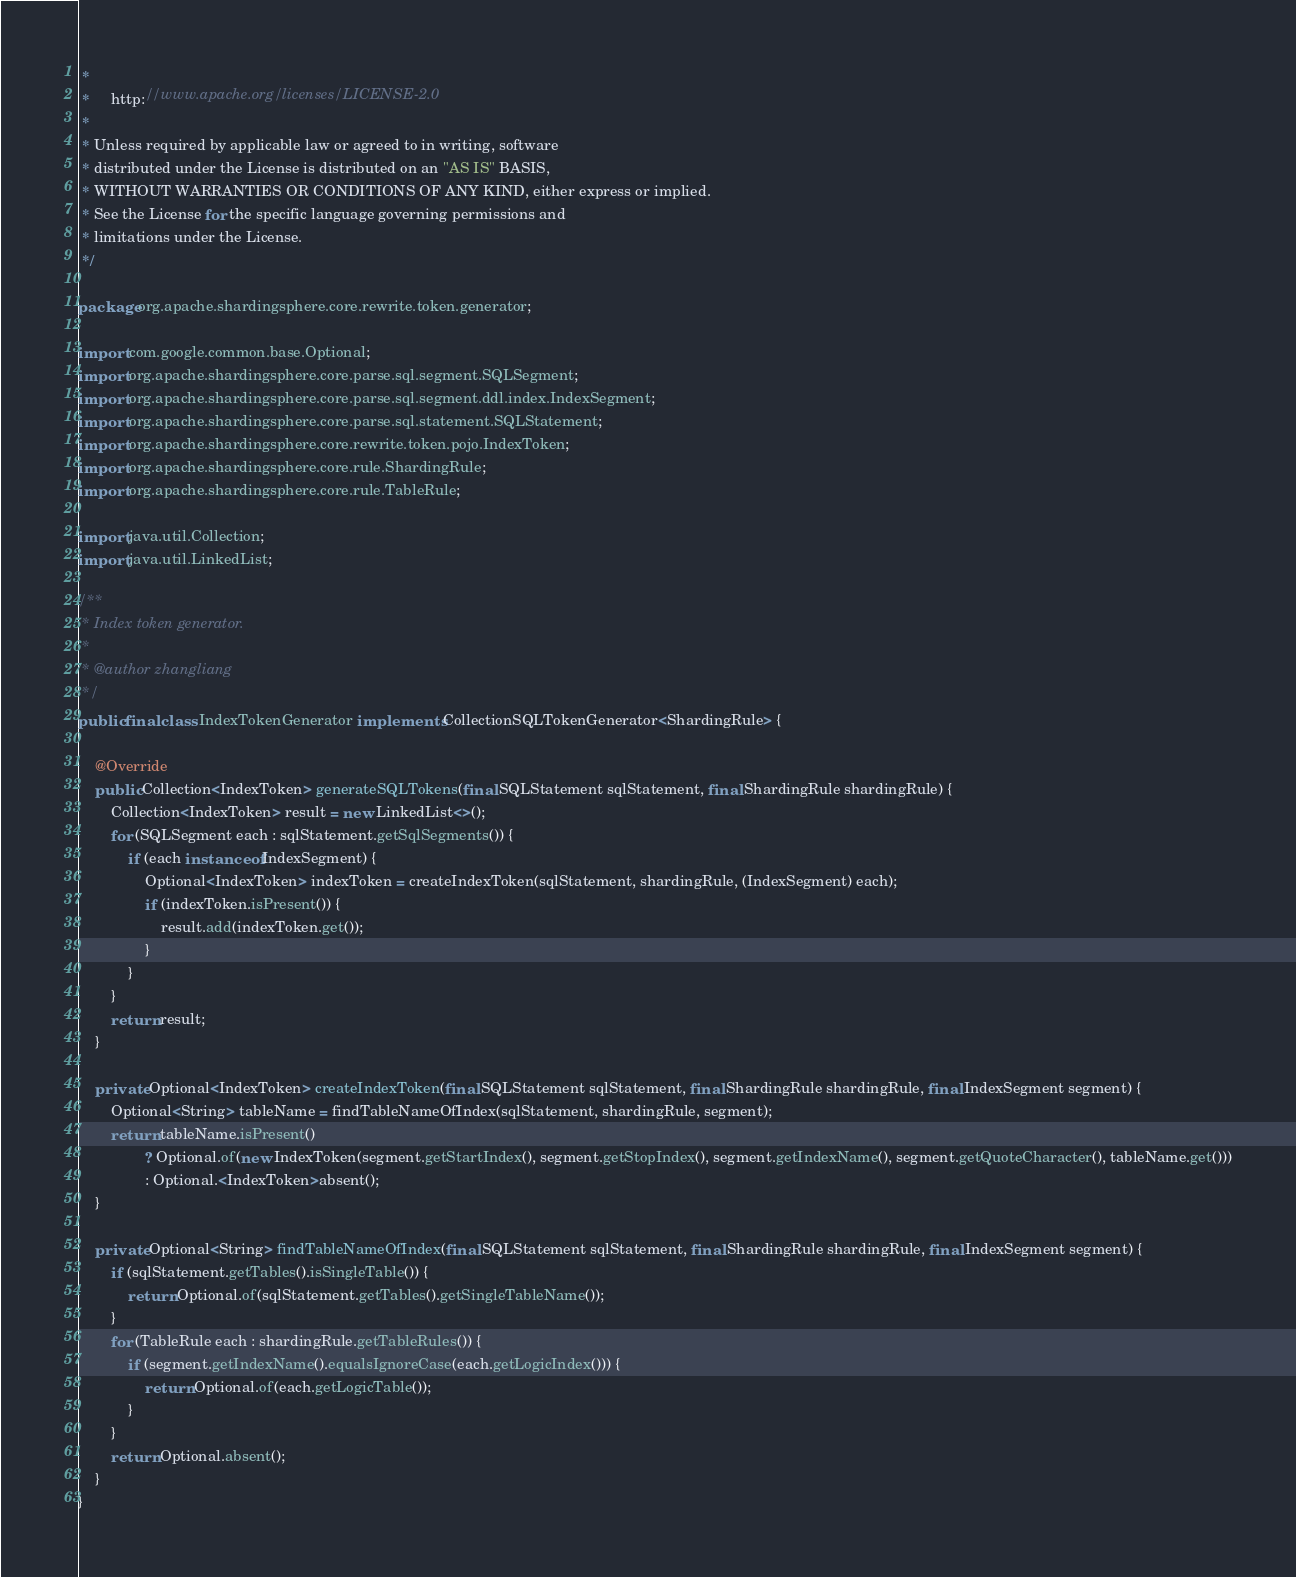<code> <loc_0><loc_0><loc_500><loc_500><_Java_> *
 *     http://www.apache.org/licenses/LICENSE-2.0
 *
 * Unless required by applicable law or agreed to in writing, software
 * distributed under the License is distributed on an "AS IS" BASIS,
 * WITHOUT WARRANTIES OR CONDITIONS OF ANY KIND, either express or implied.
 * See the License for the specific language governing permissions and
 * limitations under the License.
 */

package org.apache.shardingsphere.core.rewrite.token.generator;

import com.google.common.base.Optional;
import org.apache.shardingsphere.core.parse.sql.segment.SQLSegment;
import org.apache.shardingsphere.core.parse.sql.segment.ddl.index.IndexSegment;
import org.apache.shardingsphere.core.parse.sql.statement.SQLStatement;
import org.apache.shardingsphere.core.rewrite.token.pojo.IndexToken;
import org.apache.shardingsphere.core.rule.ShardingRule;
import org.apache.shardingsphere.core.rule.TableRule;

import java.util.Collection;
import java.util.LinkedList;

/**
 * Index token generator.
 *
 * @author zhangliang
 */
public final class IndexTokenGenerator implements CollectionSQLTokenGenerator<ShardingRule> {
    
    @Override
    public Collection<IndexToken> generateSQLTokens(final SQLStatement sqlStatement, final ShardingRule shardingRule) {
        Collection<IndexToken> result = new LinkedList<>();
        for (SQLSegment each : sqlStatement.getSqlSegments()) {
            if (each instanceof IndexSegment) {
                Optional<IndexToken> indexToken = createIndexToken(sqlStatement, shardingRule, (IndexSegment) each);
                if (indexToken.isPresent()) {
                    result.add(indexToken.get());
                }
            }
        }
        return result;
    }
    
    private Optional<IndexToken> createIndexToken(final SQLStatement sqlStatement, final ShardingRule shardingRule, final IndexSegment segment) {
        Optional<String> tableName = findTableNameOfIndex(sqlStatement, shardingRule, segment);
        return tableName.isPresent()
                ? Optional.of(new IndexToken(segment.getStartIndex(), segment.getStopIndex(), segment.getIndexName(), segment.getQuoteCharacter(), tableName.get()))
                : Optional.<IndexToken>absent();
    }
    
    private Optional<String> findTableNameOfIndex(final SQLStatement sqlStatement, final ShardingRule shardingRule, final IndexSegment segment) {
        if (sqlStatement.getTables().isSingleTable()) {
            return Optional.of(sqlStatement.getTables().getSingleTableName());
        }
        for (TableRule each : shardingRule.getTableRules()) {
            if (segment.getIndexName().equalsIgnoreCase(each.getLogicIndex())) {
                return Optional.of(each.getLogicTable());
            }
        }
        return Optional.absent();
    }
}
</code> 